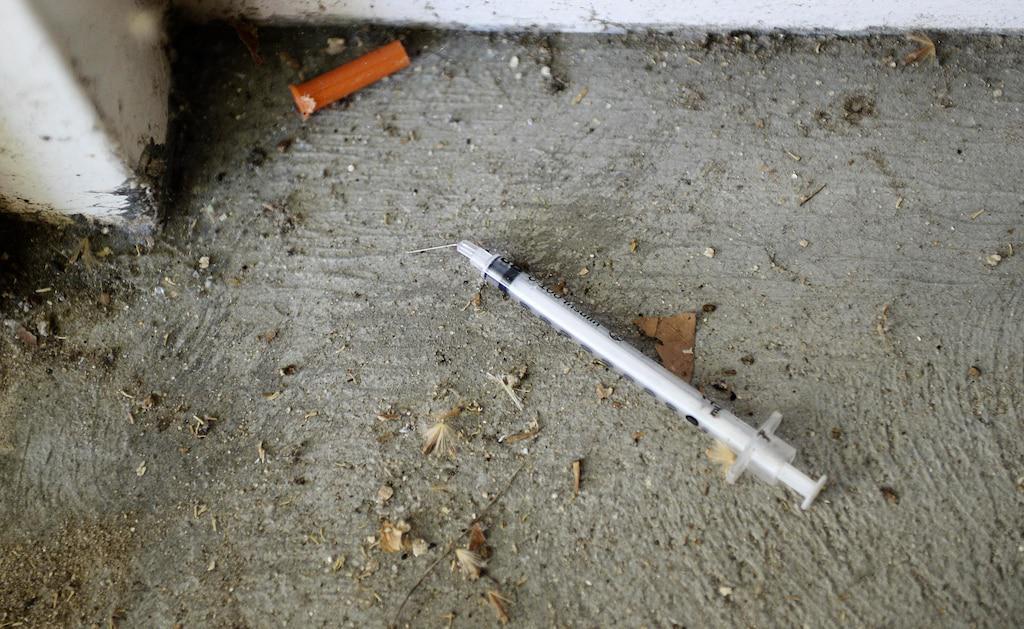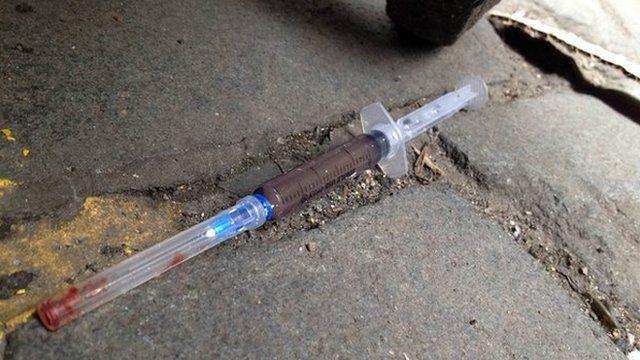The first image is the image on the left, the second image is the image on the right. Examine the images to the left and right. Is the description "Each image shows one syringe, which is on a cement-type surface." accurate? Answer yes or no. Yes. The first image is the image on the left, the second image is the image on the right. Evaluate the accuracy of this statement regarding the images: "There are two syringes lying on the floor". Is it true? Answer yes or no. Yes. 